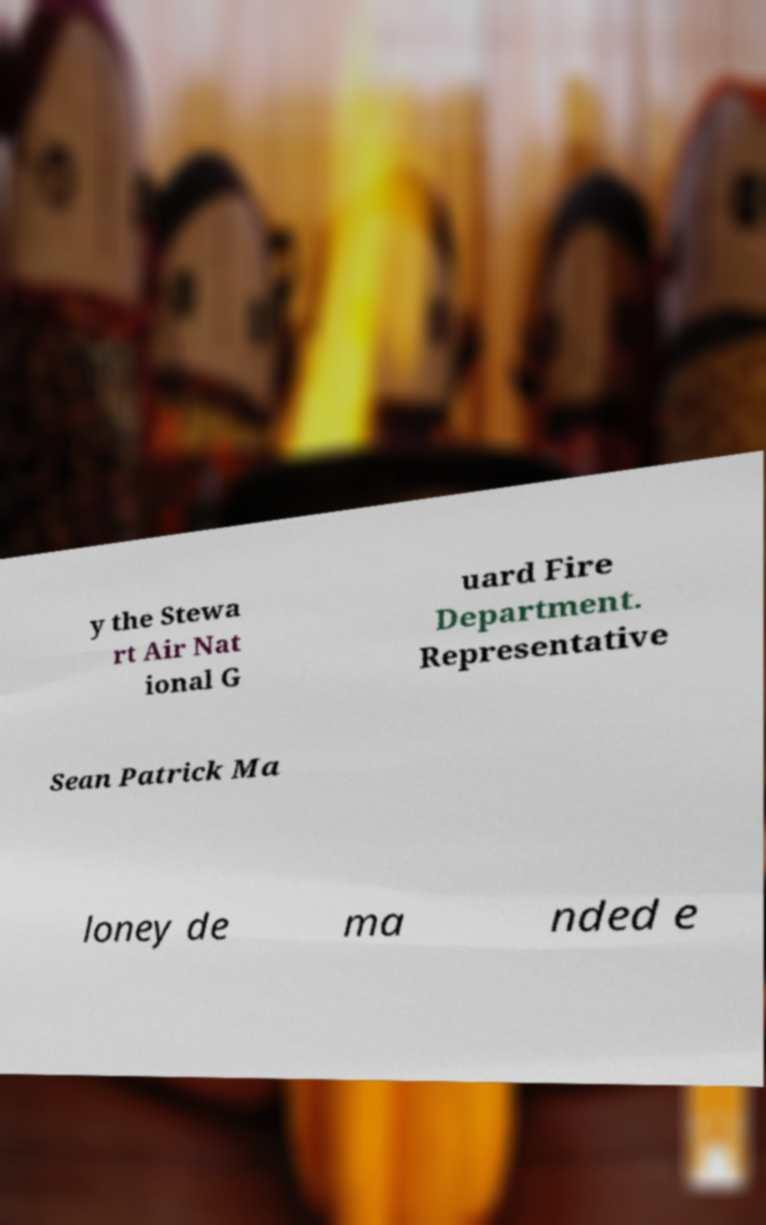Could you extract and type out the text from this image? y the Stewa rt Air Nat ional G uard Fire Department. Representative Sean Patrick Ma loney de ma nded e 